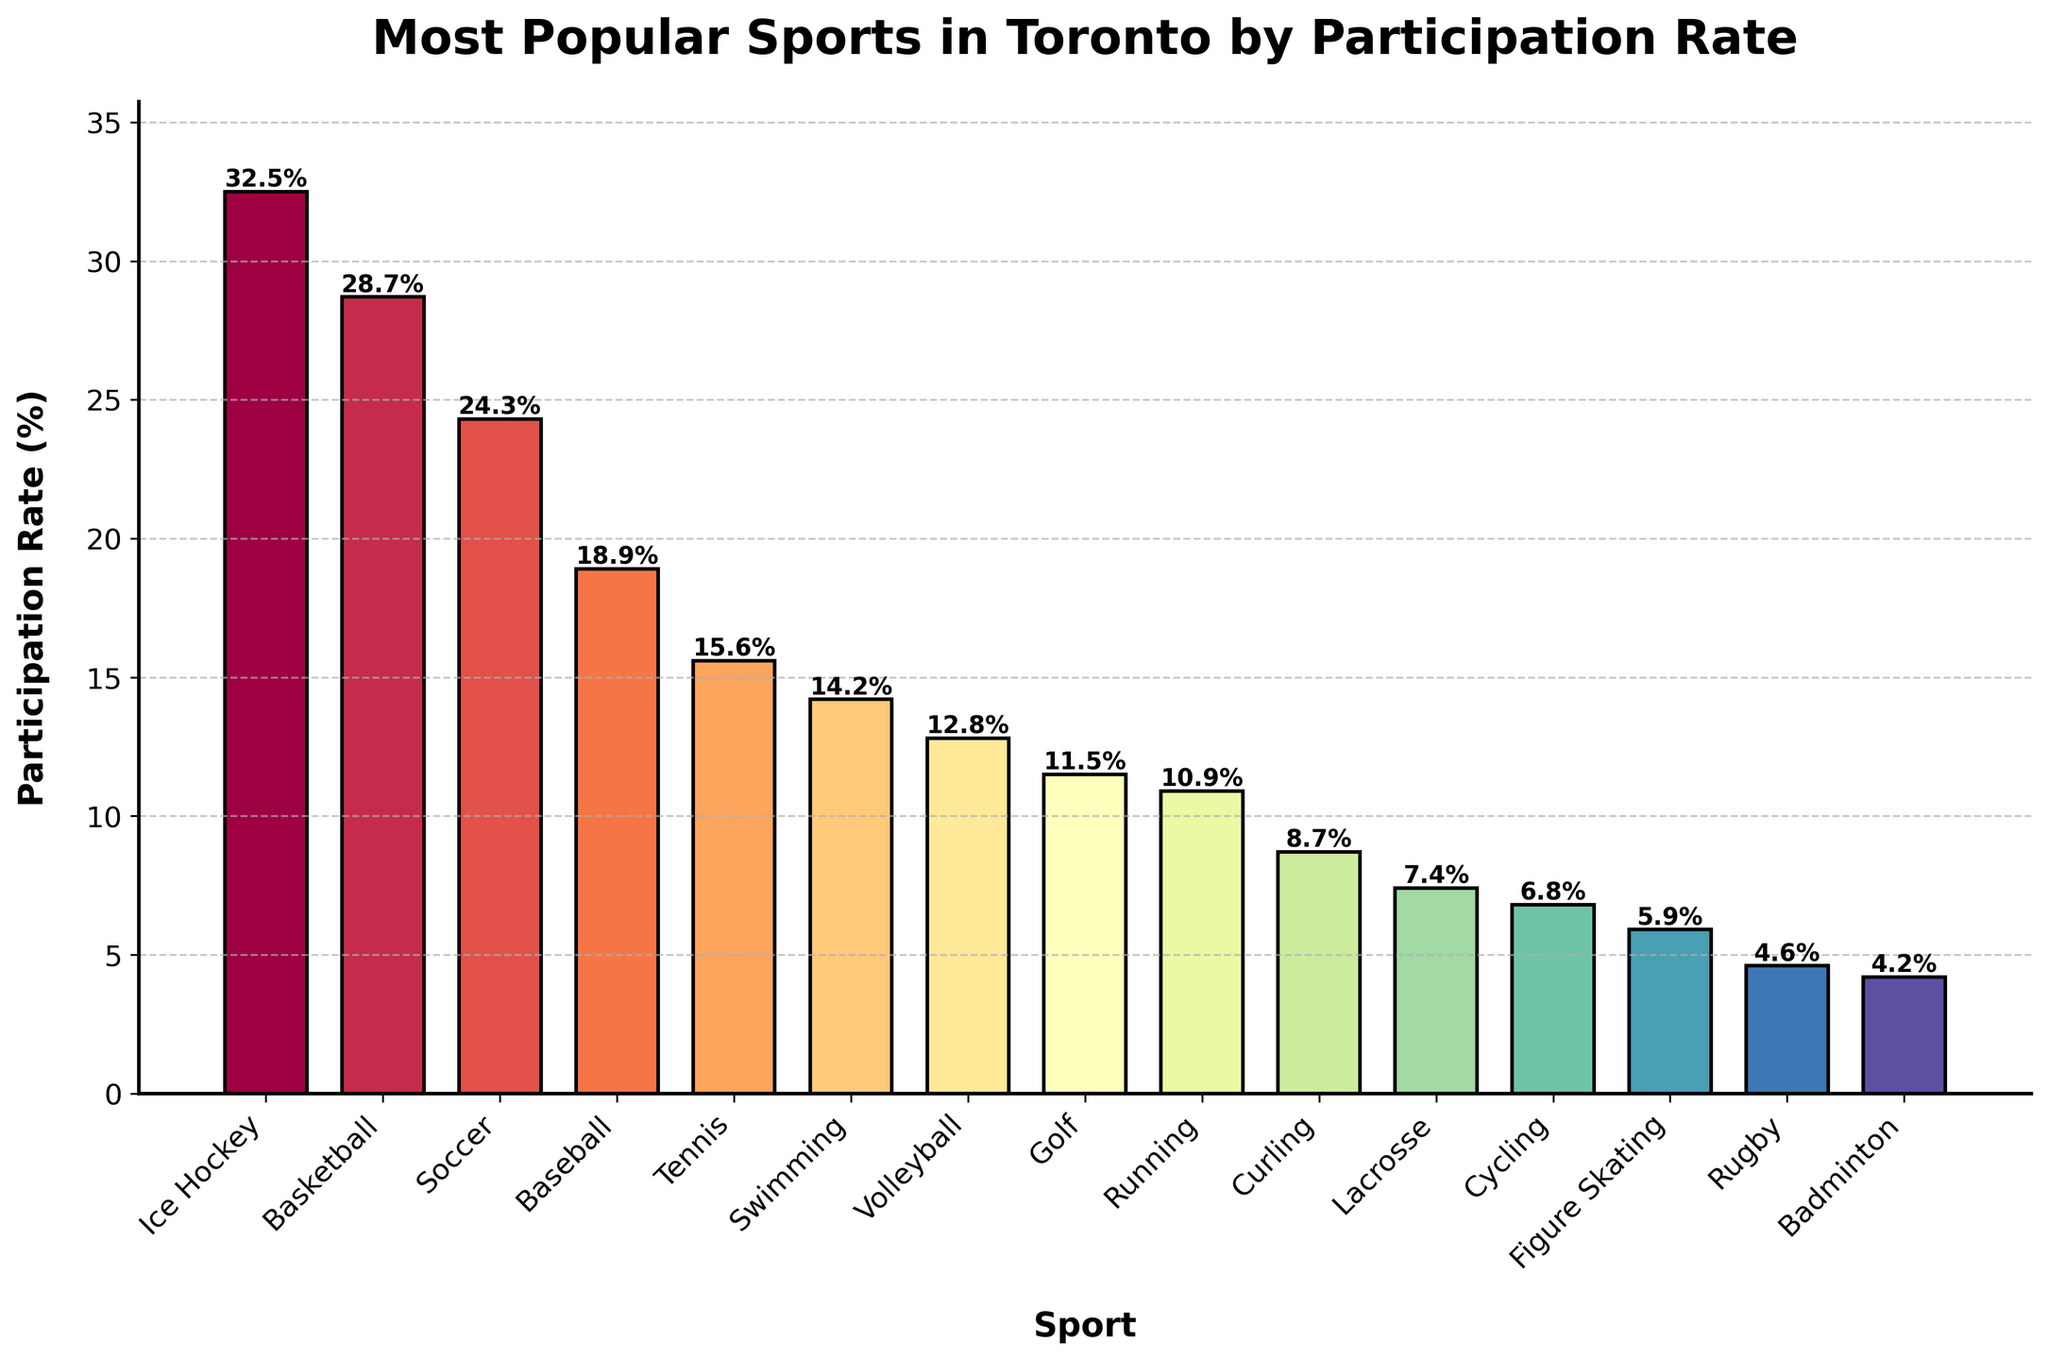Which sport has the highest participation rate? By looking at the bar chart, identify the sport with the tallest bar, which represents the highest participation rate.
Answer: Ice Hockey What is the difference in participation rates between Ice Hockey and Soccer? Note the participation rate of Ice Hockey (32.5%) and the participation rate of Soccer (24.3%). Subtract the smaller rate from the larger rate: 32.5% - 24.3% = 8.2%.
Answer: 8.2% Which sport has a lower participation rate: Basketball or Baseball? Compare the heights of the bars for Basketball and Baseball. Basketball has a participation rate of 28.7%, and Baseball has a participation rate of 18.9%. 18.9% is lower than 28.7%.
Answer: Baseball Are there any sports with a participation rate less than 10%? If yes, list them. Identify the bars that are below the 10% mark on the y-axis. The participation rates of Curling (8.7%), Lacrosse (7.4%), Cycling (6.8%), Figure Skating (5.9%), Rugby (4.6%), and Badminton (4.2%) are all below 10%.
Answer: Curling, Lacrosse, Cycling, Figure Skating, Rugby, Badminton What's the combined participation rate of the top three most popular sports? Identify the top three sports by participation rate: Ice Hockey (32.5%), Basketball (28.7%), and Soccer (24.3%). Sum these three values: 32.5% + 28.7% + 24.3% = 85.5%.
Answer: 85.5% Which sport is just above Badminton in terms of participation rate? Look for the bar representing Badminton with a participation rate of 4.2% and identify the bar immediately above it: Rugby at 4.6%.
Answer: Rugby How much higher is the participation rate of Tennis compared to Volleyball? Note the participation rates of Tennis (15.6%) and Volleyball (12.8%). Subtract the smaller rate from the larger rate: 15.6% - 12.8% = 2.8%.
Answer: 2.8% Among Swimming, Golf, and Running, which sport has the highest participation rate? Compare the heights of the bars for Swimming (14.2%), Golf (11.5%), and Running (10.9%). Swimming has the highest participation rate among the three.
Answer: Swimming How does the participation rate of Lacrosse compare to that of Cycling? Compare the heights of the bars for Lacrosse (7.4%) and Cycling (6.8%). Lacrosse's rate is higher than Cycling's rate.
Answer: Lacrosse What is the participation rate range for the listed sports? Identify the highest participation rate (Ice Hockey at 32.5%) and the lowest (Badminton at 4.2%). Subtract the lowest rate from the highest: 32.5% - 4.2% = 28.3%.
Answer: 28.3% 